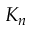<formula> <loc_0><loc_0><loc_500><loc_500>K _ { n }</formula> 